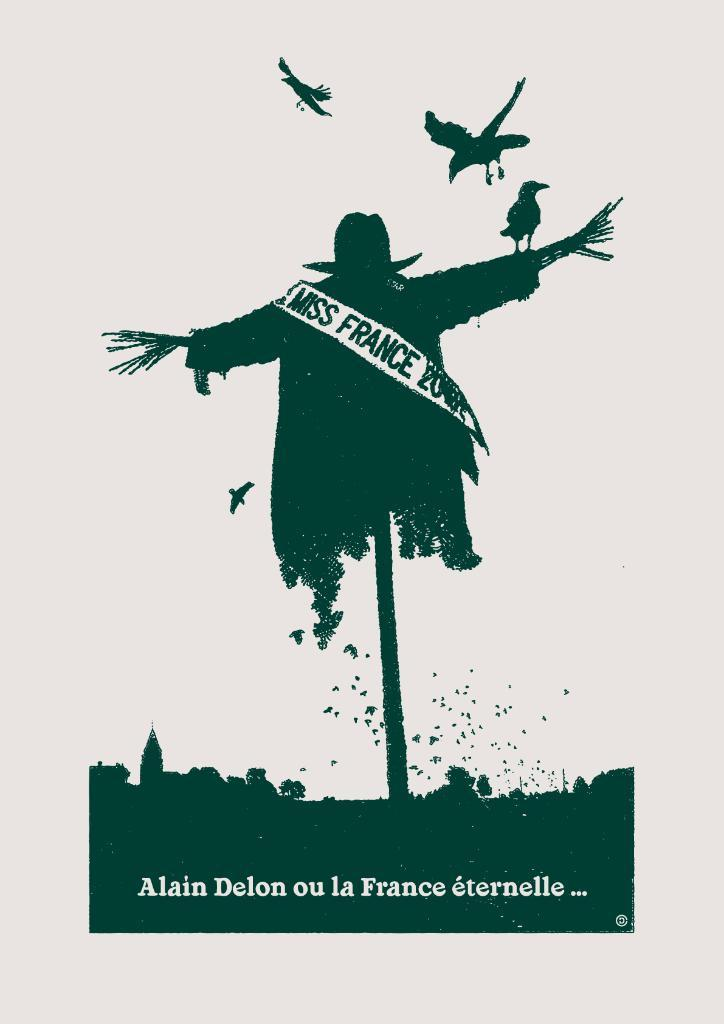What is depicted in the painting in the image? There is a painting of a person in the image. What other living creatures can be seen in the image? There are birds present in the image. What additional information is provided on the painting? There is text on the painting. How many children are playing with the sheep in the image? There are no children or sheep present in the image. 